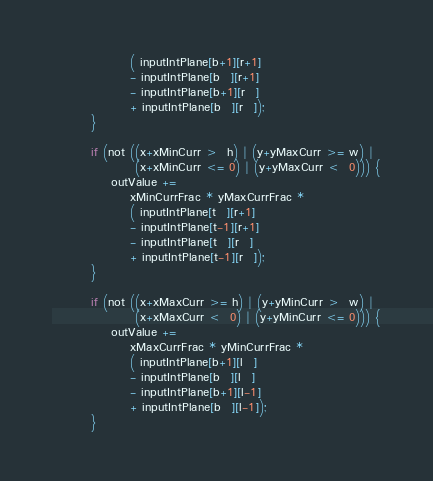Convert code to text. <code><loc_0><loc_0><loc_500><loc_500><_Cuda_>                ( inputIntPlane[b+1][r+1]
                - inputIntPlane[b  ][r+1]
                - inputIntPlane[b+1][r  ]
                + inputIntPlane[b  ][r  ]);
        }

        if (not ((x+xMinCurr >  h) | (y+yMaxCurr >= w) |
                 (x+xMinCurr <= 0) | (y+yMaxCurr <  0))) {
            outValue +=
                xMinCurrFrac * yMaxCurrFrac *
                ( inputIntPlane[t  ][r+1]
                - inputIntPlane[t-1][r+1]
                - inputIntPlane[t  ][r  ]
                + inputIntPlane[t-1][r  ]);
        }

        if (not ((x+xMaxCurr >= h) | (y+yMinCurr >  w) |
                 (x+xMaxCurr <  0) | (y+yMinCurr <= 0))) {
            outValue +=
                xMaxCurrFrac * yMinCurrFrac *
                ( inputIntPlane[b+1][l  ]
                - inputIntPlane[b  ][l  ]
                - inputIntPlane[b+1][l-1]
                + inputIntPlane[b  ][l-1]);
        }
</code> 